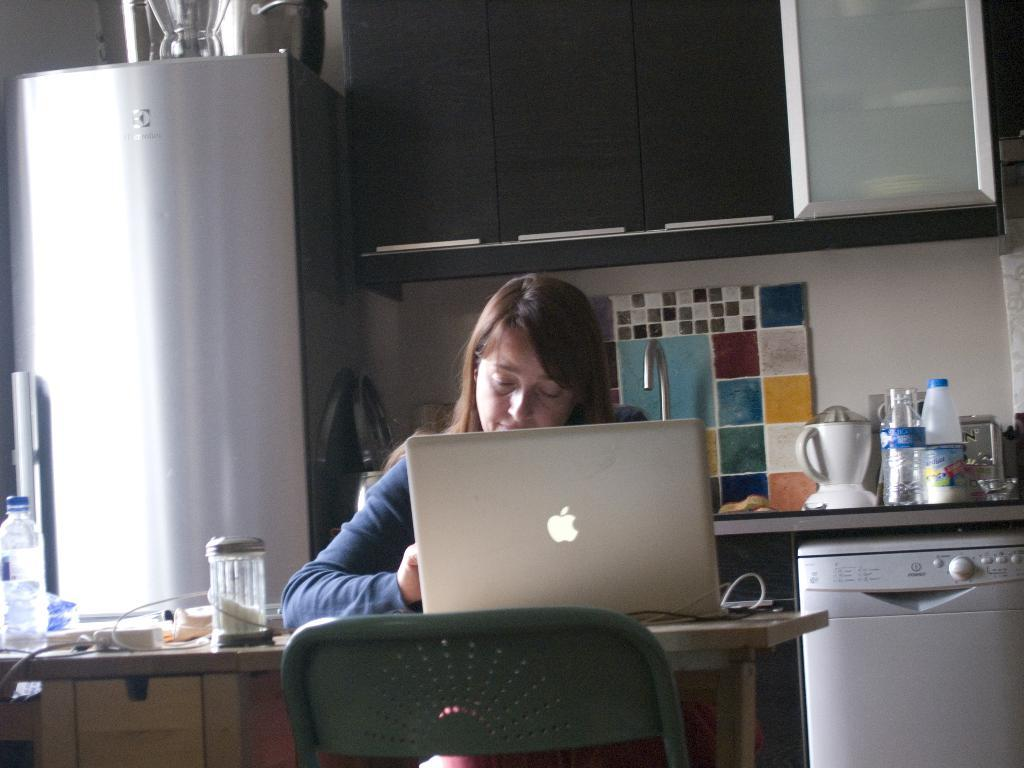What is on the table in the image? There is a laptop on a table in the image. Who is using the laptop? A lady is operating the laptop. What can be seen in the background of the image? There is a refrigerator, a wooden cupboard, and kitchen utensils in the background. Can you see any deer in the image? No, there are no deer present in the image. What type of brush is being used to paint the cave in the image? There is no cave or brush present in the image. 